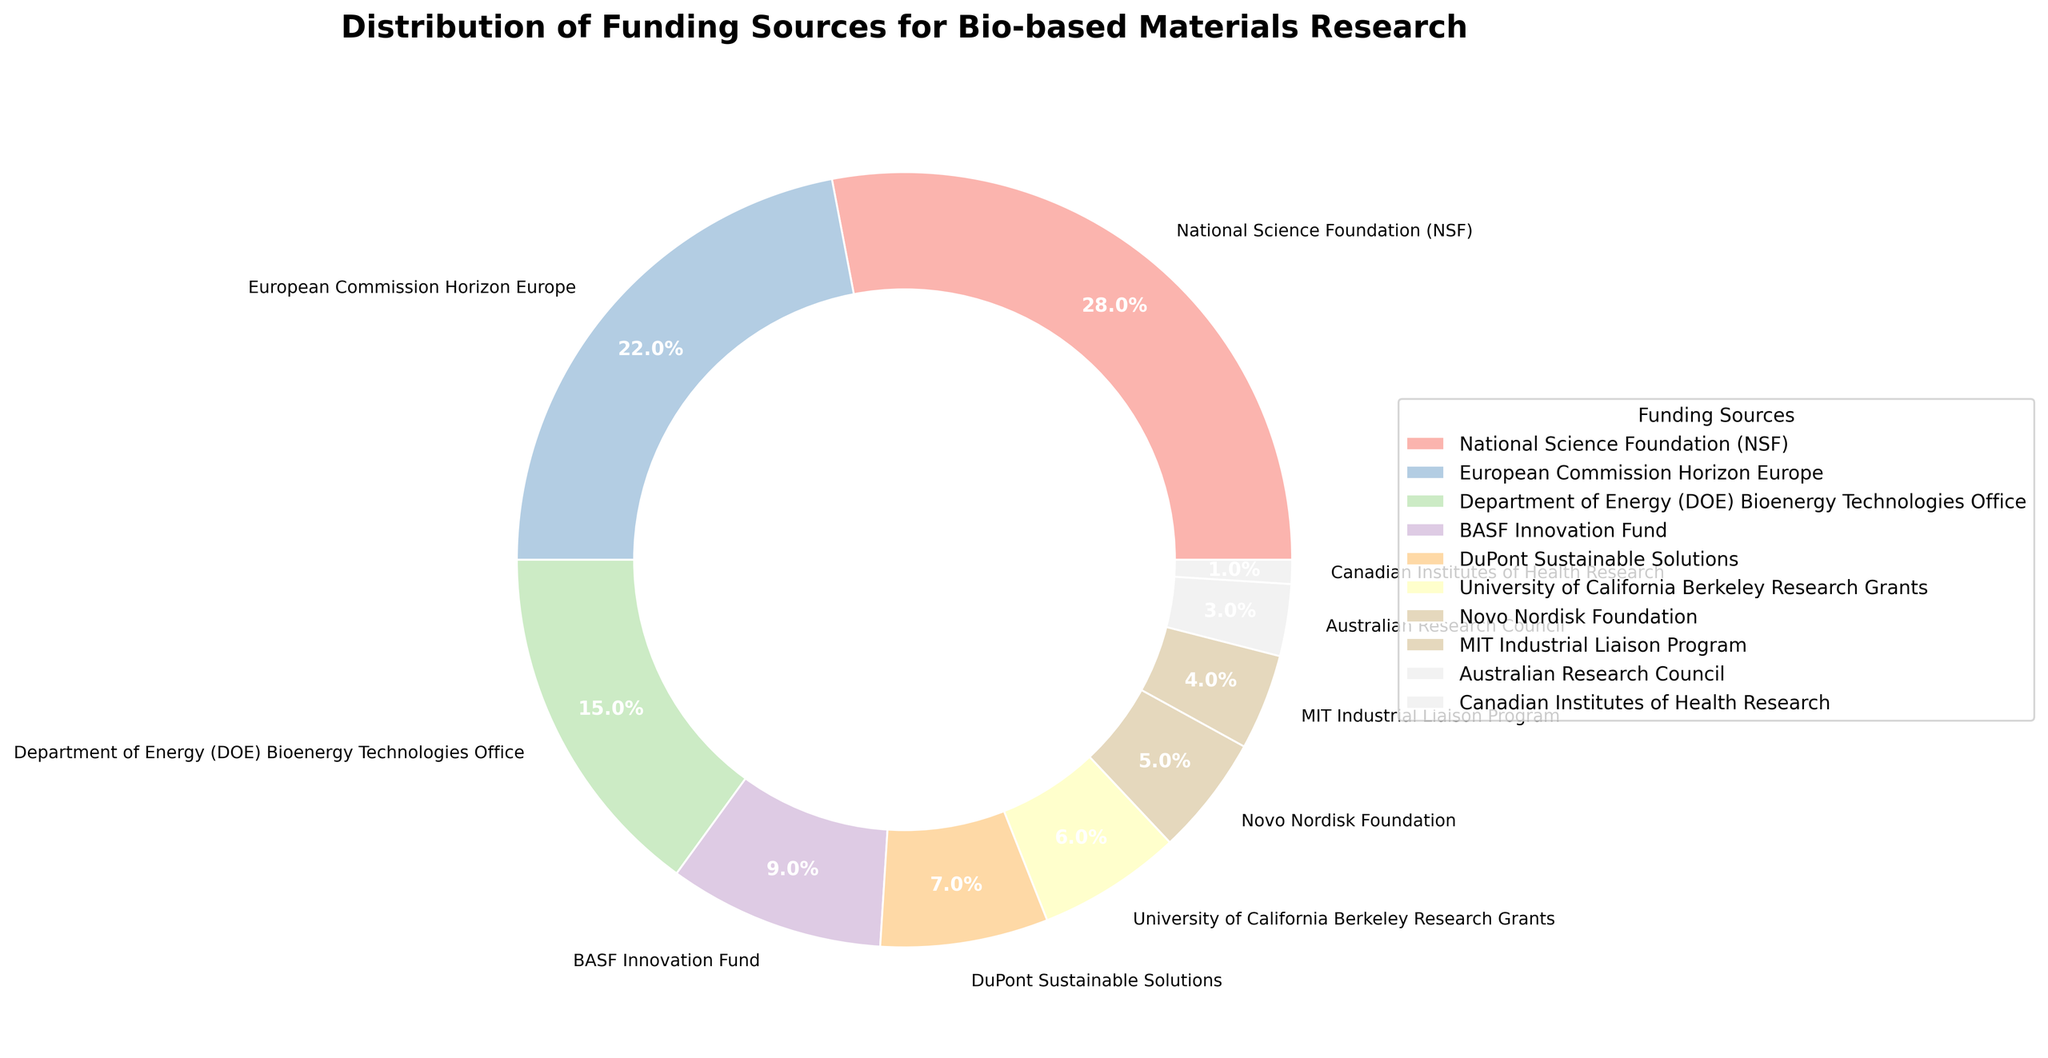What are the top three funding sources for bio-based materials research by percentage? Look at the figure and identify the segments with the highest percentages. The top three segments are National Science Foundation (28%), European Commission Horizon Europe (22%), and Department of Energy (15%).
Answer: NSF, Horizon Europe, DOE What is the total percentage of funding contributed by private sector sources (BASF Innovation Fund and DuPont Sustainable Solutions)? Sum the percentages of BASF Innovation Fund (9%) and DuPont Sustainable Solutions (7%). The total is 9% + 7%, which equals 16%.
Answer: 16% Which funding source provides the least support for bio-based materials research? Identify the smallest segment in the pie chart by percentage. The smallest segment is Canadian Institutes of Health Research at 1%.
Answer: Canadian Institutes of Health Research How does the funding percentage of the University of California Berkeley Research Grants compare to that of the Novo Nordisk Foundation? Compare the percentages of the two segments. University of California Berkeley Research Grants has 6%, while Novo Nordisk Foundation has 5%. Therefore, UC Berkeley has a 1% higher funding percentage.
Answer: UC Berkeley has 1% more What is the combined percentage of funding provided by government grants (NSF, Horizon Europe, DOE, and Australian Research Council)? Sum the percentages of NSF (28%), Horizon Europe (22%), DOE (15%), and Australian Research Council (3%). The total is 28% + 22% + 15% + 3%, which equals 68%.
Answer: 68% Are there more funding sources from academic institutions or government agencies? Count the number of funding sources from each category. Academic institutions: University of California Berkeley Research Grants (1), MIT Industrial Liaison Program (1). Government agencies: NSF (1), Horizon Europe (1), DOE (1), Australian Research Council (1), Canadian Institutes of Health Research (1). There are 2 from academic institutions and 5 from government agencies.
Answer: Government agencies Which sector (government, private, or academic) contributes the highest proportion of funding overall? Compare the summed percentages of the segments belonging to each sector. Government: 28% (NSF) + 22% (Horizon Europe) + 15% (DOE) + 3% (Australian Research Council) + 1% (CIHR) = 69%. Private: 9% (BASF) + 7% (DuPont) + 5% (Novo Nordisk) = 21%. Academic: 6% (UC Berkeley) + 4% (MIT) = 10%. Government sector contributes the highest proportion.
Answer: Government sector What percentage of the funding is provided by European organizations or agencies? Identify and sum the percentages of segments related to European organizations. Horizon Europe (22%) and Novo Nordisk Foundation (5%) are the related ones. The total is 22% + 5%, which equals 27%.
Answer: 27% 